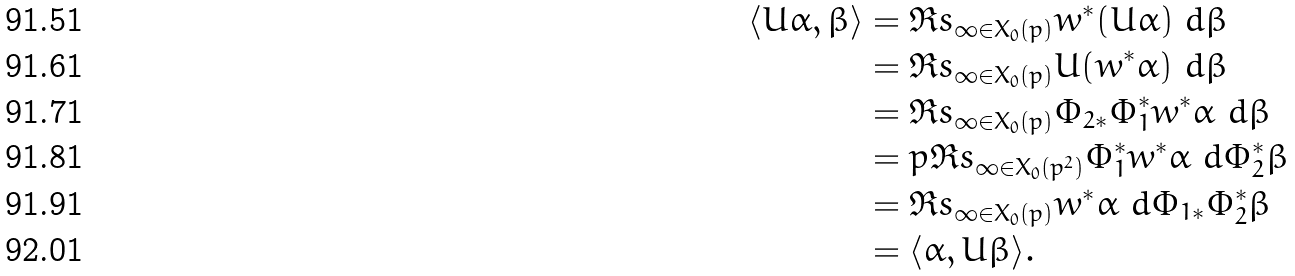<formula> <loc_0><loc_0><loc_500><loc_500>\langle U \alpha , \beta \rangle & = \Re s _ { \infty \in X _ { 0 } ( p ) } w ^ { * } ( U \alpha ) \ d \beta \\ & = \Re s _ { \infty \in X _ { 0 } ( p ) } U ( w ^ { * } \alpha ) \ d \beta \\ & = \Re s _ { \infty \in X _ { 0 } ( p ) } \Phi _ { 2 * } \Phi _ { 1 } ^ { * } w ^ { * } \alpha \ d \beta \\ & = p \Re s _ { \infty \in X _ { 0 } ( p ^ { 2 } ) } \Phi _ { 1 } ^ { * } w ^ { * } \alpha \ d \Phi _ { 2 } ^ { * } \beta \\ & = \Re s _ { \infty \in X _ { 0 } ( p ) } w ^ { * } \alpha \ d \Phi _ { 1 * } \Phi _ { 2 } ^ { * } \beta \\ & = \langle \alpha , U \beta \rangle .</formula> 